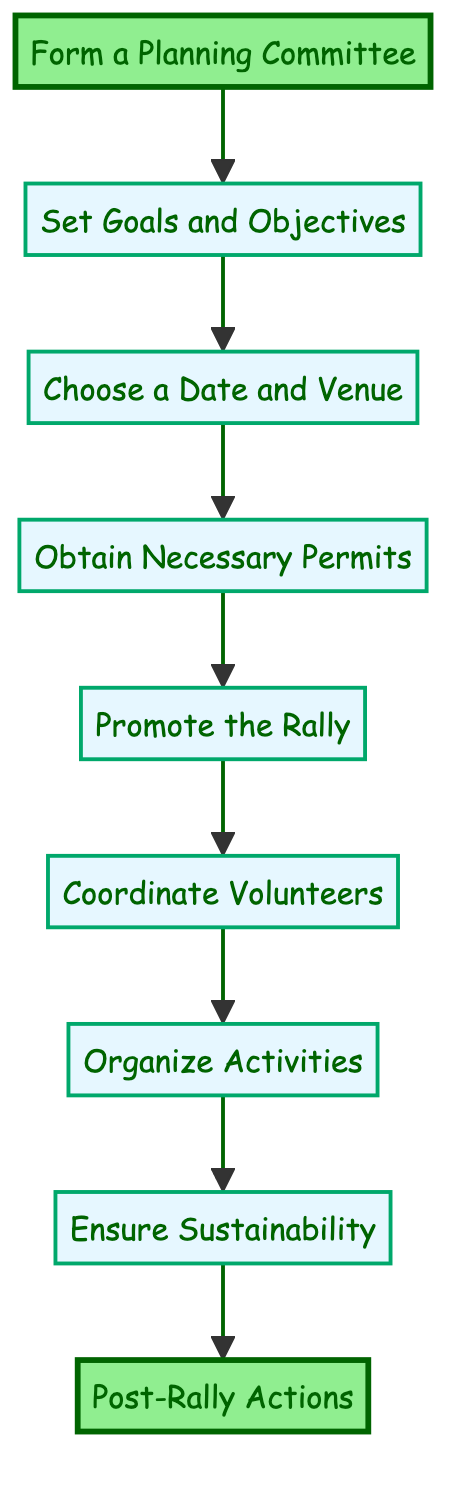What is the first step in organizing the rally? The diagram indicates that the first step in the flow chart is to "Form a Planning Committee". This is the first node in the sequence of steps outlined for the rally organization.
Answer: Form a Planning Committee How many total steps are there in the diagram? By counting the nodes in the flow chart, we see there are a total of nine steps listed from the starting point to the final action.
Answer: Nine What step comes after "Choose a Date and Venue"? The flow chart shows that "Obtain Necessary Permits" is the next step that follows "Choose a Date and Venue", indicated by the direct arrow leading from one node to the other.
Answer: Obtain Necessary Permits Which steps are emphasized in the diagram with a different color? In the flow chart, the first and last steps ("Form a Planning Committee" and "Post-Rally Actions") are highlighted with a different color, showing they are emphasized compared to the other steps in the sequence.
Answer: Form a Planning Committee and Post-Rally Actions What are two types of activities mentioned in the "Organize Activities" step? The description of the "Organize Activities" step specifies activities such as "eco-themed comic drawing contests" and "workshops on sustainable practices.” These two types illustrate the focus on engagement and education in eco-friendly actions.
Answer: Eco-themed comic drawing contests, Workshops on sustainable practices Why is the "Ensure Sustainability" step important in the rally organization? This step is crucial as it outlines concrete actions to promote eco-friendliness during the rally, such as setting up recycling stations and encouraging participants to bring reusable items. This reinforces the rally's goal of sustainability.
Answer: To promote eco-friendliness during the rally What can be inferred about the flow of the diagram from the "Promote the Rally" step to "Coordinate Volunteers"? The direct connection from "Promote the Rally" to "Coordinate Volunteers" suggests that after spreading awareness about the rally, the next action is to organize and prepare volunteers. This shows a logical progression where promotion leads to volunteer engagement.
Answer: Promotion leads to volunteer organization What is the final step in the Eco-friendly Community Rally organization process? The final action as per the flow is labeled "Post-Rally Actions," which encapsulates the need for follow-up and continued engagement after the event has concluded. This highlights the ongoing commitment to the cause represented by the rally.
Answer: Post-Rally Actions 